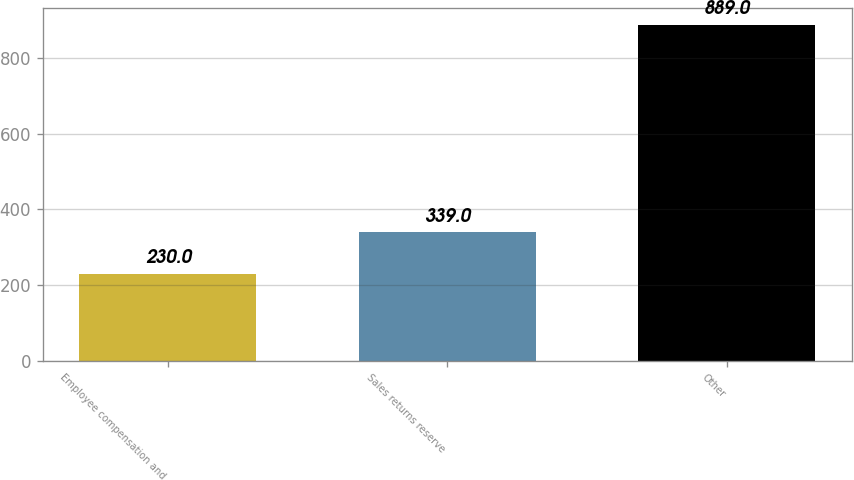Convert chart. <chart><loc_0><loc_0><loc_500><loc_500><bar_chart><fcel>Employee compensation and<fcel>Sales returns reserve<fcel>Other<nl><fcel>230<fcel>339<fcel>889<nl></chart> 